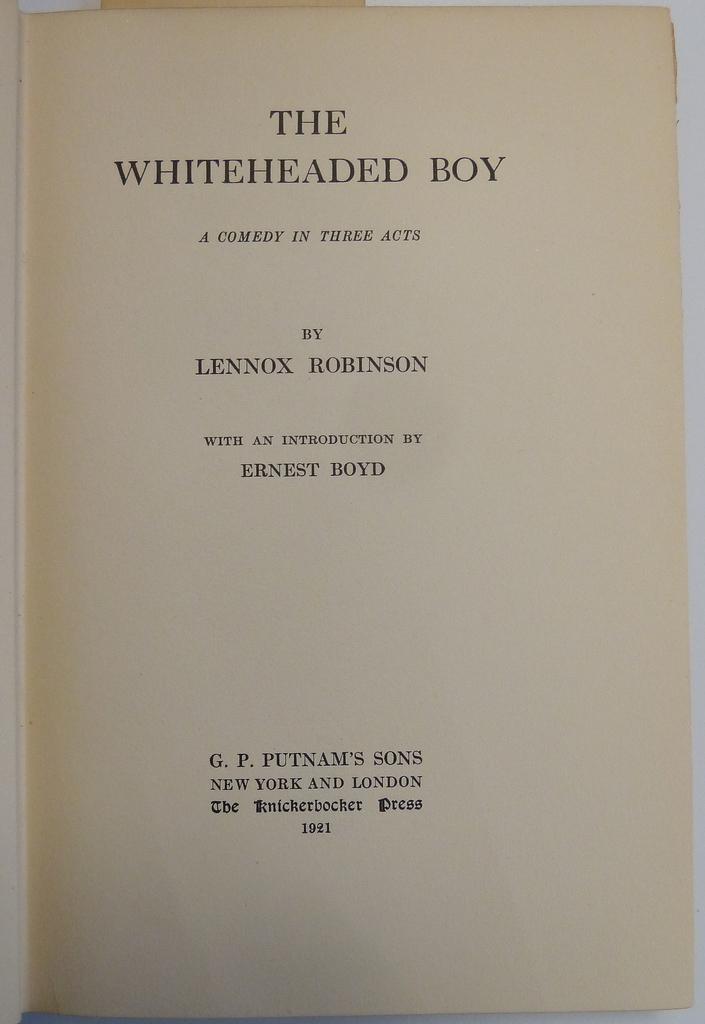What is the title of the play?
Make the answer very short. The whiteheaded boy. Who wrote the play?
Your answer should be compact. Lennox robinson. 